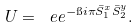Convert formula to latex. <formula><loc_0><loc_0><loc_500><loc_500>U = \ e e ^ { - \i i \pi \bar { S } _ { 1 } ^ { x } \bar { S } _ { 2 } ^ { y } } .</formula> 